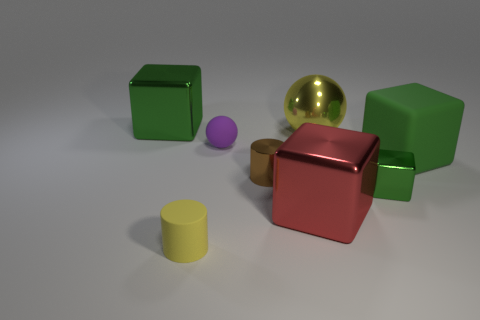Does the metal sphere have the same color as the cylinder in front of the tiny green shiny cube?
Offer a very short reply. Yes. Are there any big things on the right side of the block that is left of the tiny metal object to the left of the tiny cube?
Offer a terse response. Yes. There is a big red thing that is the same material as the tiny green thing; what is its shape?
Your response must be concise. Cube. The large red object has what shape?
Provide a short and direct response. Cube. Do the metal object that is on the left side of the yellow cylinder and the large yellow metal thing have the same shape?
Your answer should be very brief. No. Is the number of tiny purple rubber things to the right of the big yellow thing greater than the number of big shiny balls in front of the small green shiny block?
Offer a terse response. No. How many other things are there of the same size as the red shiny object?
Ensure brevity in your answer.  3. There is a tiny brown thing; does it have the same shape as the yellow thing that is in front of the purple matte ball?
Your response must be concise. Yes. What number of metallic objects are red things or purple balls?
Give a very brief answer. 1. Is there a tiny cylinder that has the same color as the shiny ball?
Your answer should be very brief. Yes. 